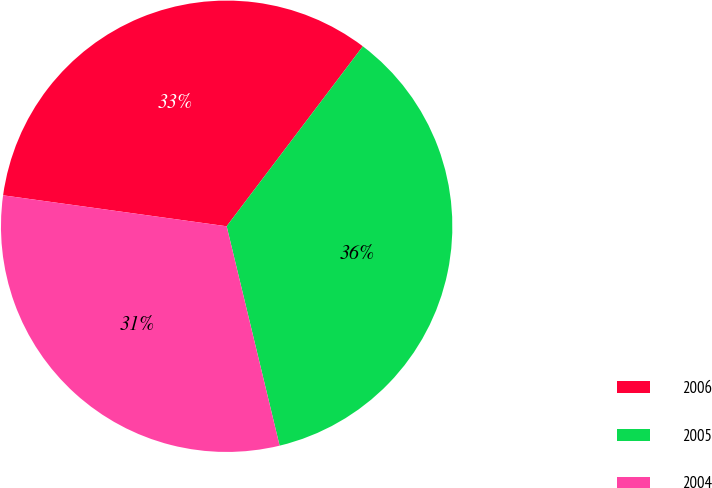Convert chart. <chart><loc_0><loc_0><loc_500><loc_500><pie_chart><fcel>2006<fcel>2005<fcel>2004<nl><fcel>33.12%<fcel>35.92%<fcel>30.96%<nl></chart> 